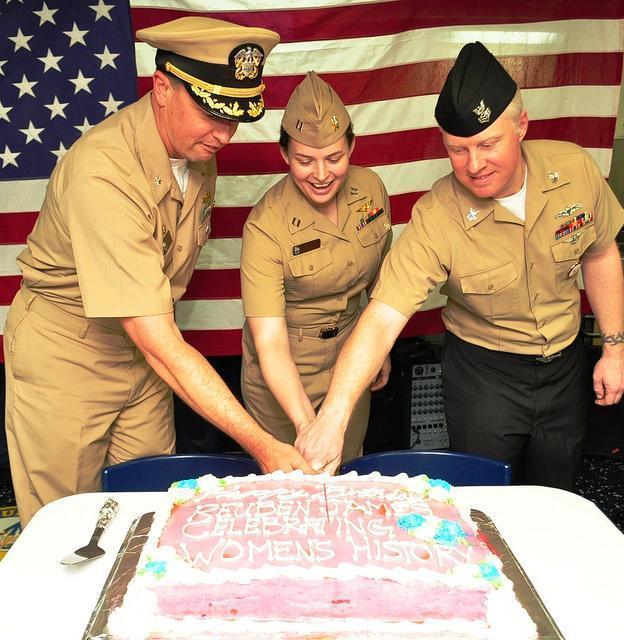How many people are shown?
Give a very brief answer. 3. How many chairs are there?
Give a very brief answer. 2. How many people are there?
Give a very brief answer. 2. 